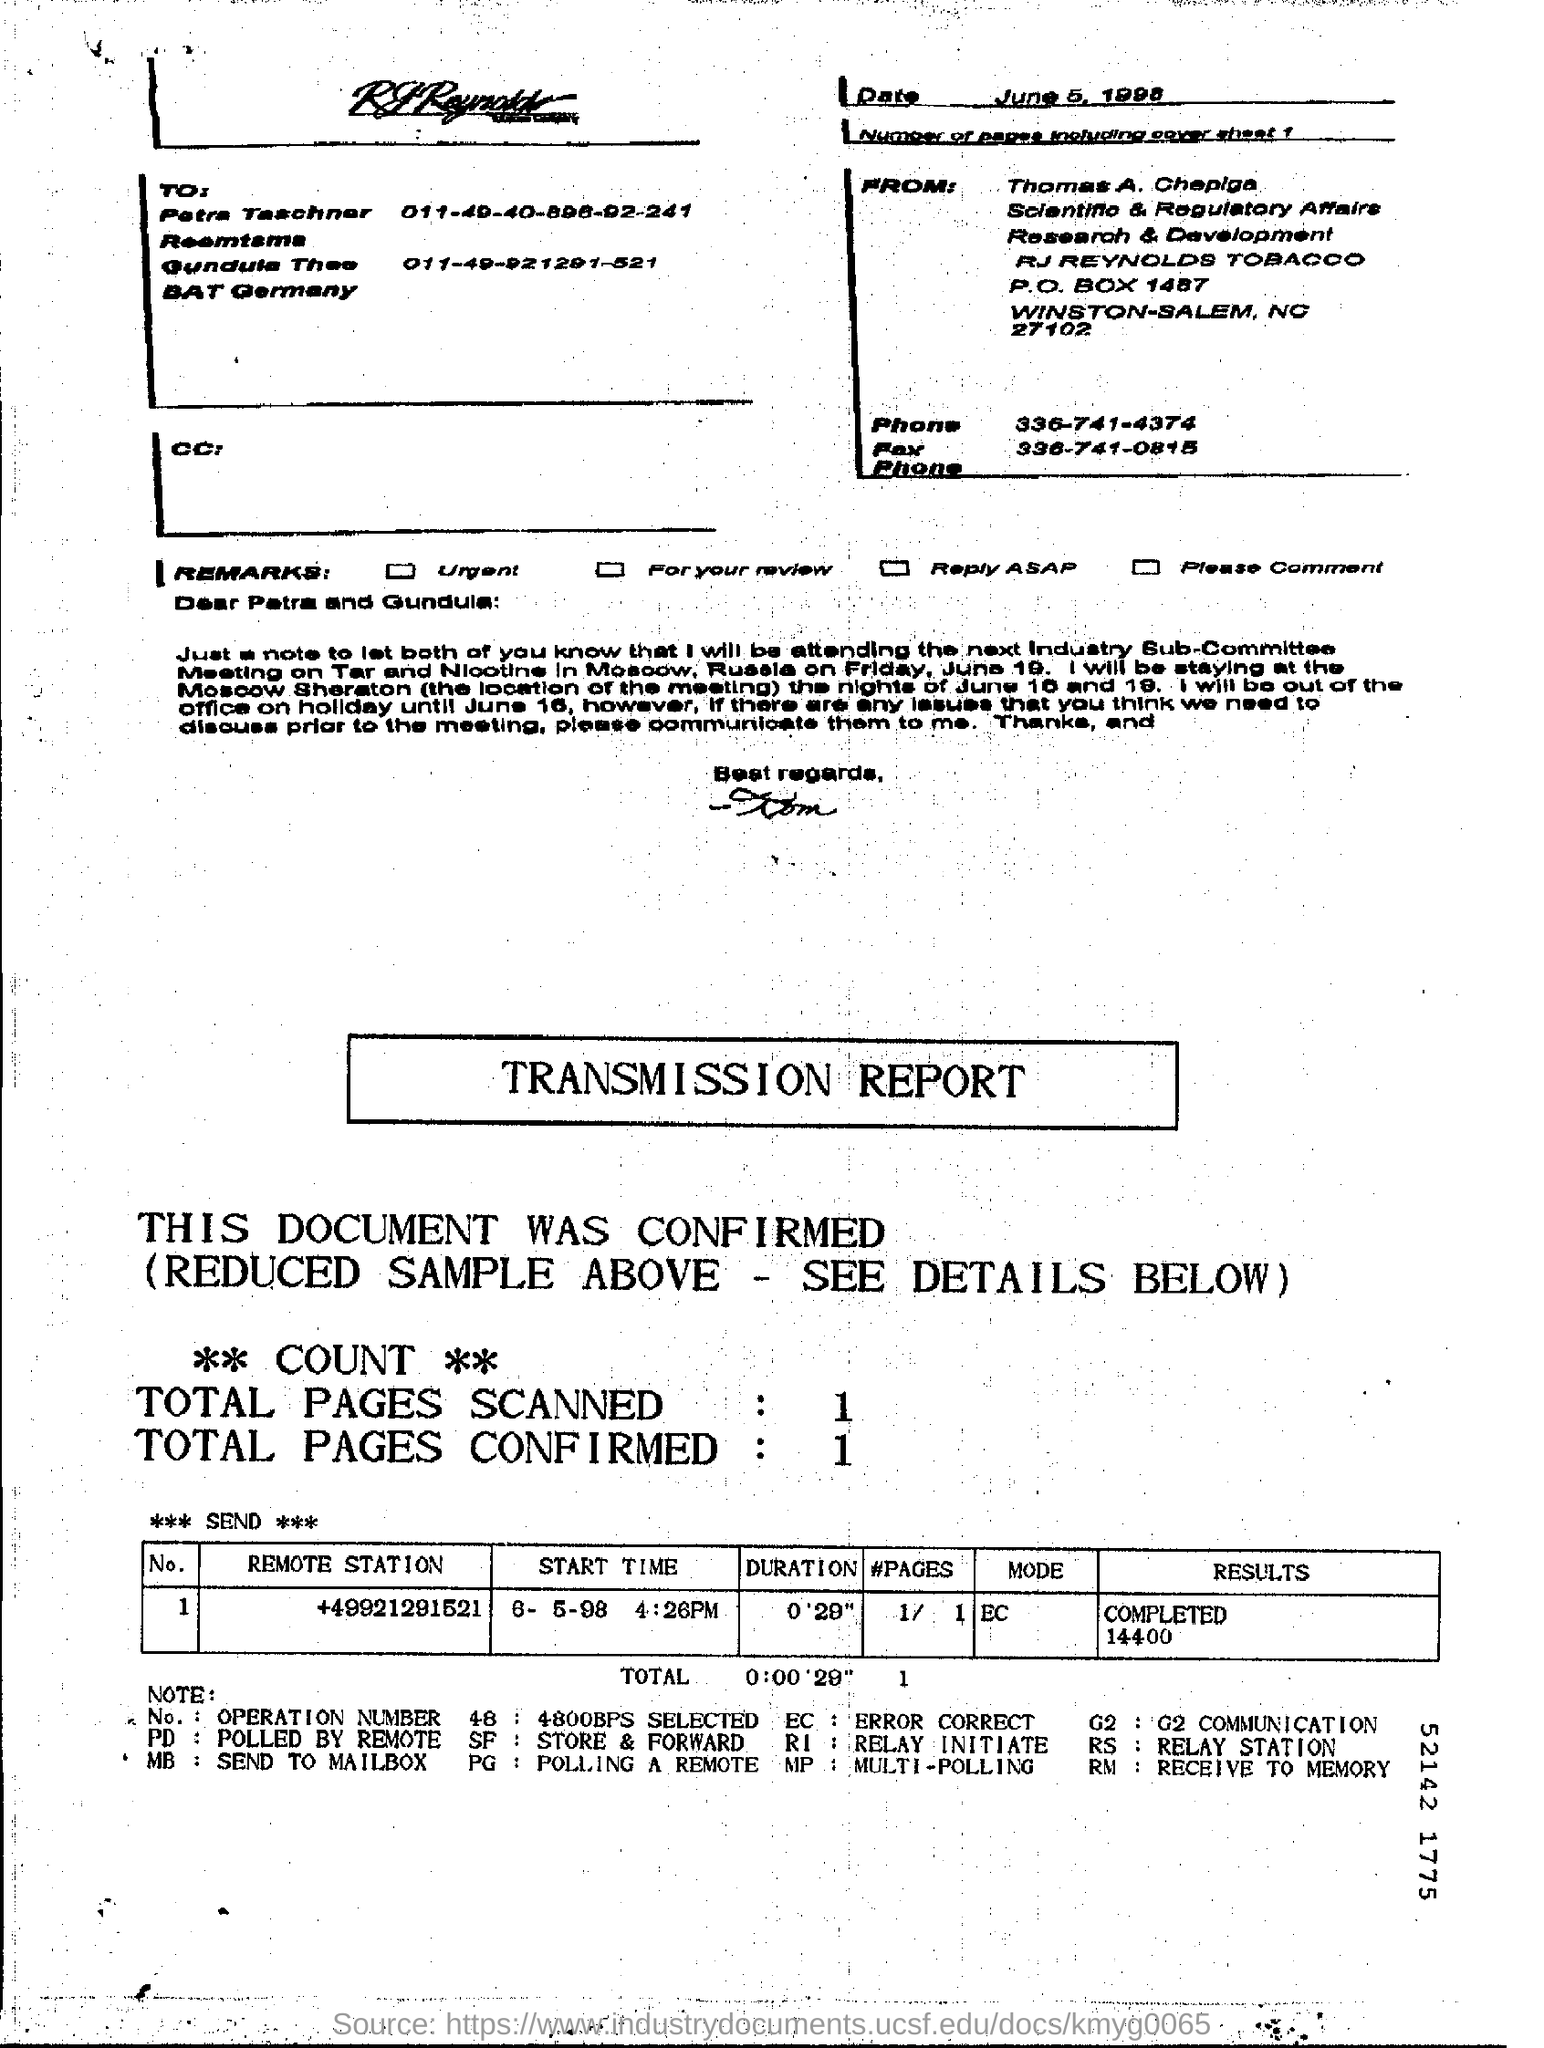In total how many pages were confirmed?
 1 